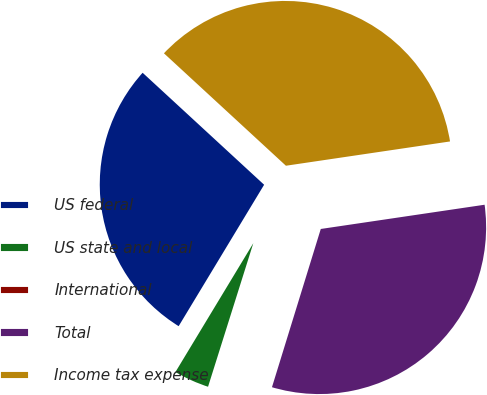<chart> <loc_0><loc_0><loc_500><loc_500><pie_chart><fcel>US federal<fcel>US state and local<fcel>International<fcel>Total<fcel>Income tax expense<nl><fcel>28.2%<fcel>3.79%<fcel>0.1%<fcel>32.1%<fcel>35.81%<nl></chart> 